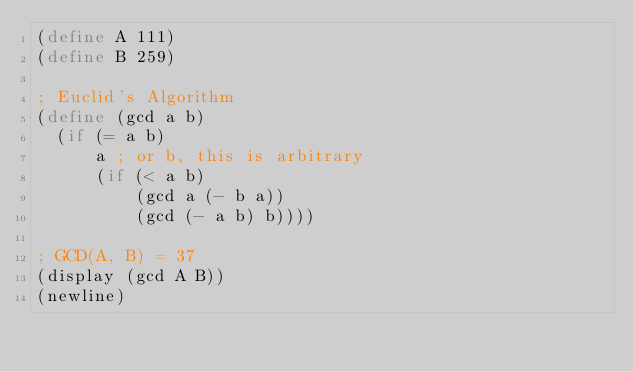Convert code to text. <code><loc_0><loc_0><loc_500><loc_500><_Scheme_>(define A 111)
(define B 259)

; Euclid's Algorithm
(define (gcd a b)
  (if (= a b)
      a ; or b, this is arbitrary
      (if (< a b)
          (gcd a (- b a))
          (gcd (- a b) b))))

; GCD(A, B) = 37
(display (gcd A B))
(newline)
</code> 